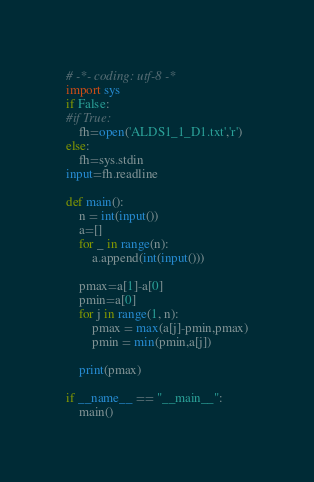<code> <loc_0><loc_0><loc_500><loc_500><_Python_># -*- coding: utf-8 -*
import sys
if False:
#if True:
    fh=open('ALDS1_1_D1.txt','r')
else:
    fh=sys.stdin
input=fh.readline

def main():
    n = int(input())
    a=[]
    for _ in range(n):
        a.append(int(input()))

    pmax=a[1]-a[0]
    pmin=a[0]
    for j in range(1, n):
        pmax = max(a[j]-pmin,pmax)
        pmin = min(pmin,a[j])

    print(pmax)
    
if __name__ == "__main__":
    main()

</code> 